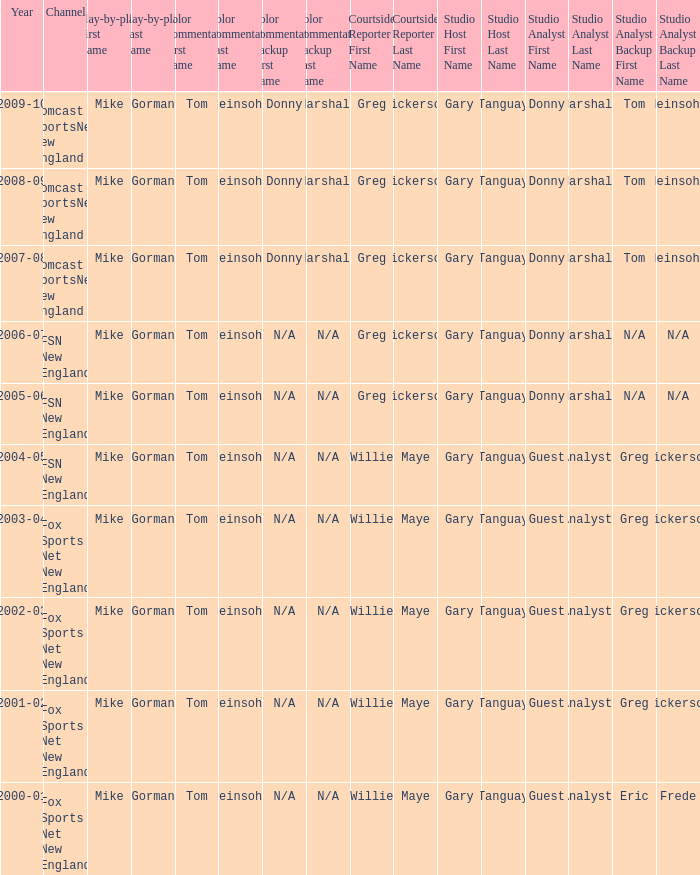During 2009-10, which studio analysts worked with a studio host by the name of gary tanguay? Donny Marshall or Tom Heinsohn (Select road games). 